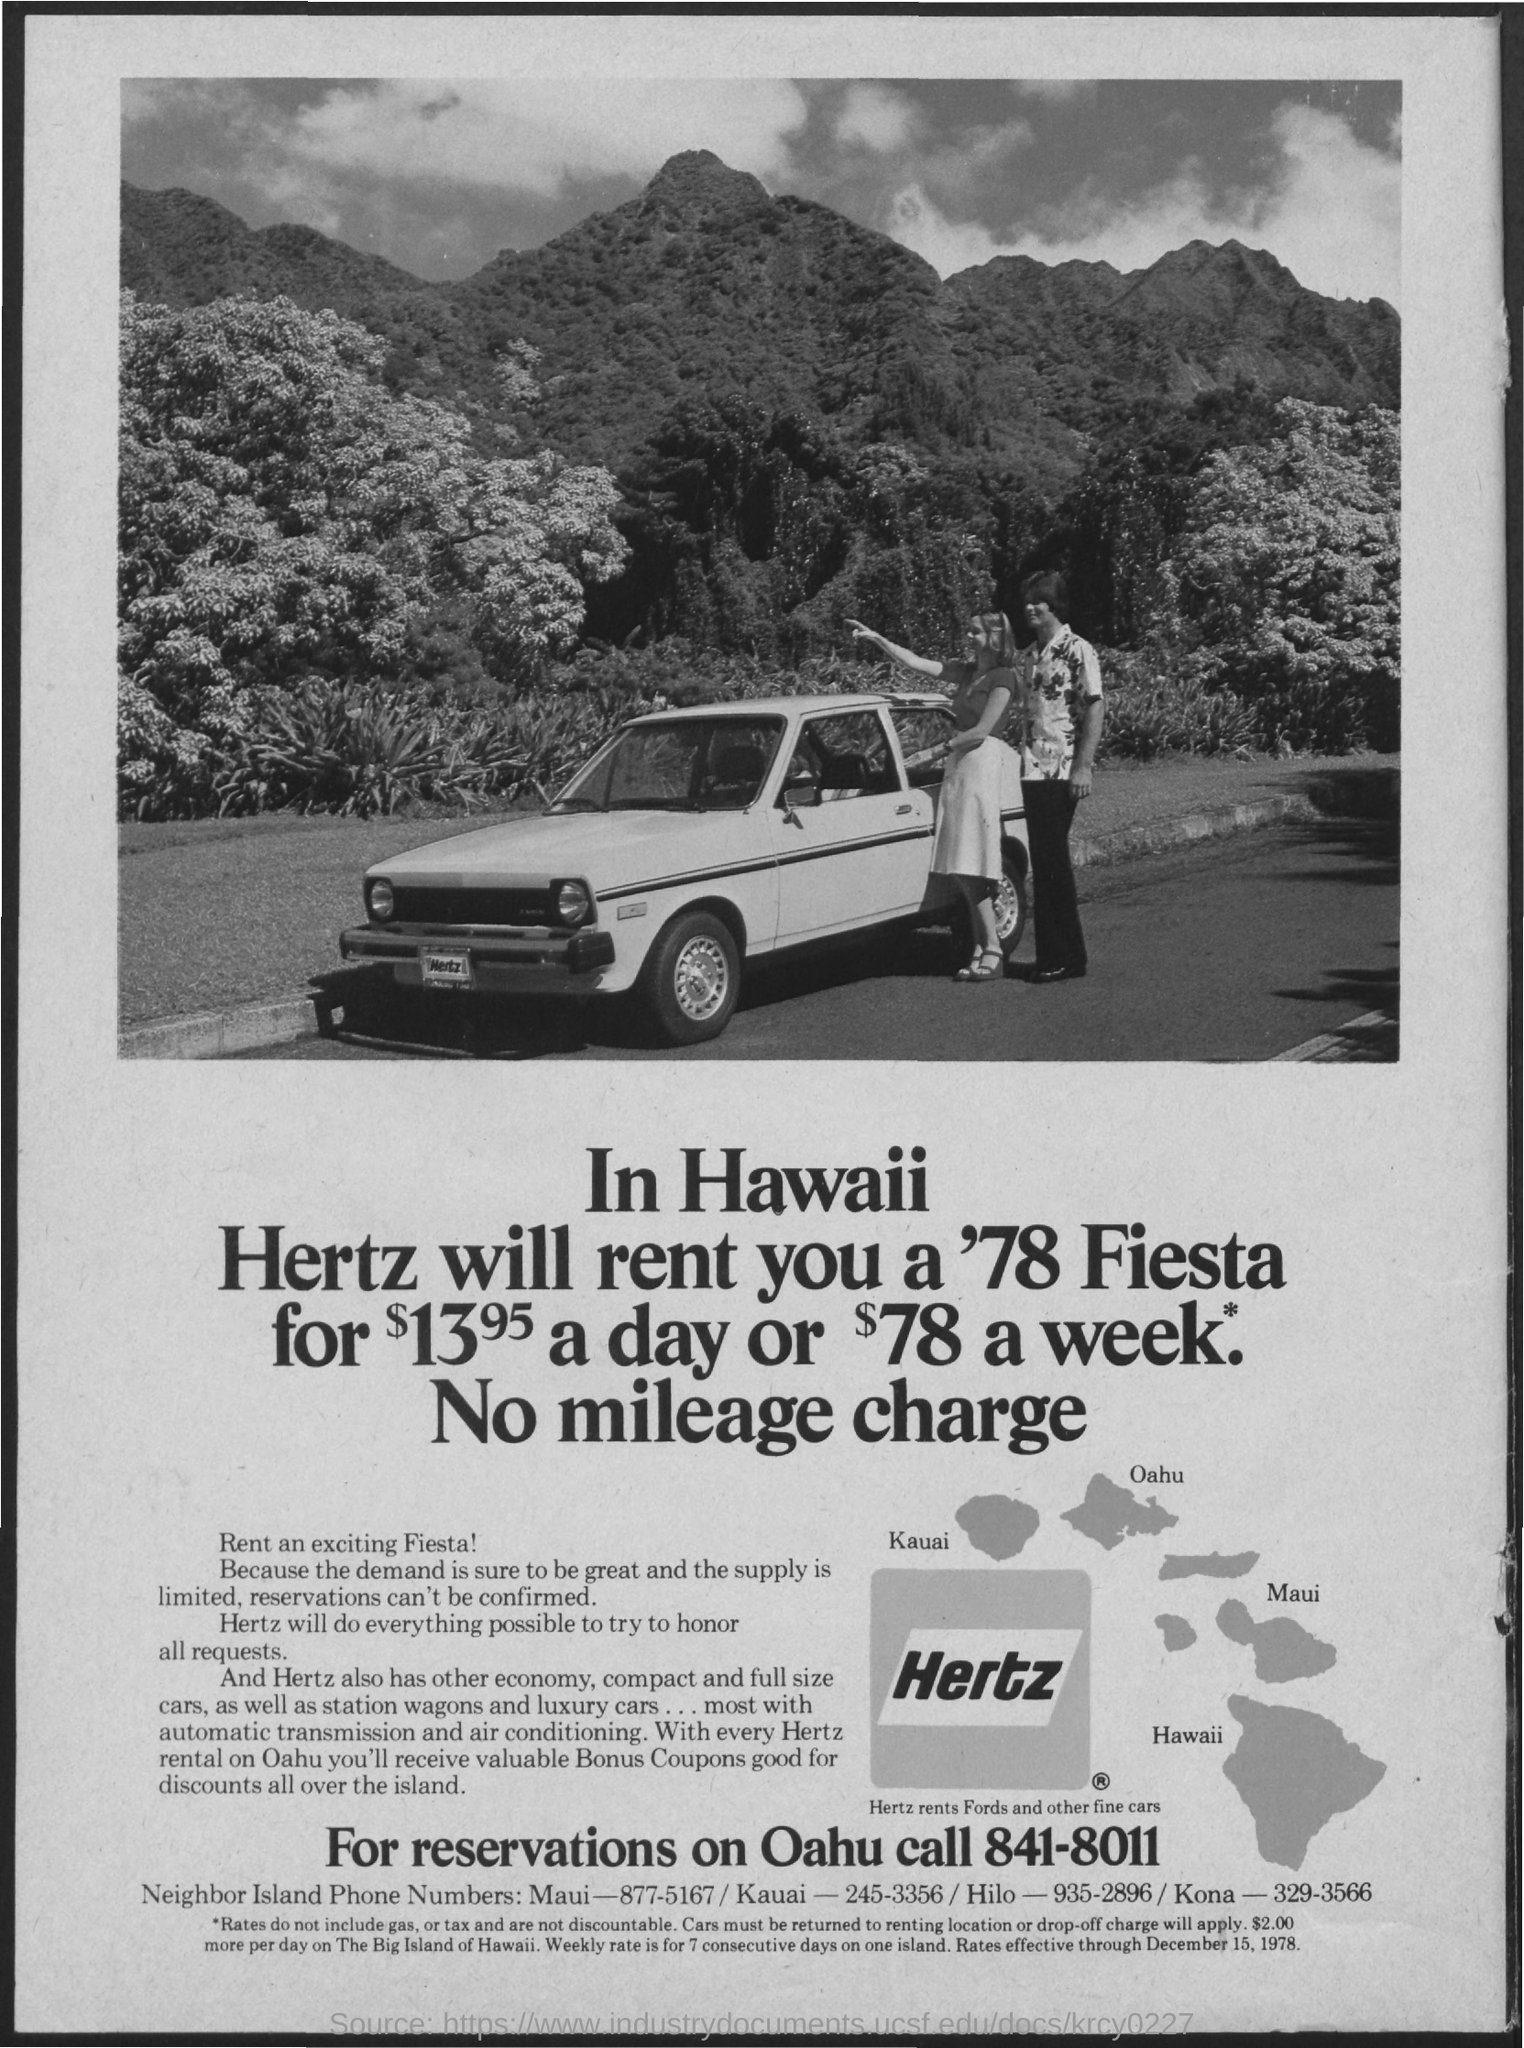What is the contact for reservation on oahu?
Provide a short and direct response. 841-8011. What is the neighbor island phone number for maui?
Ensure brevity in your answer.  877-5167. What is the neighbor island phone number for kauai?
Your response must be concise. 245-3356. What is the neighbor island phone number for hilo?
Keep it short and to the point. 935-2896. What is the neighbor island phone number for kona?
Your answer should be compact. 329-3566. When are rates effective through?
Ensure brevity in your answer.  December 15, 1978. 